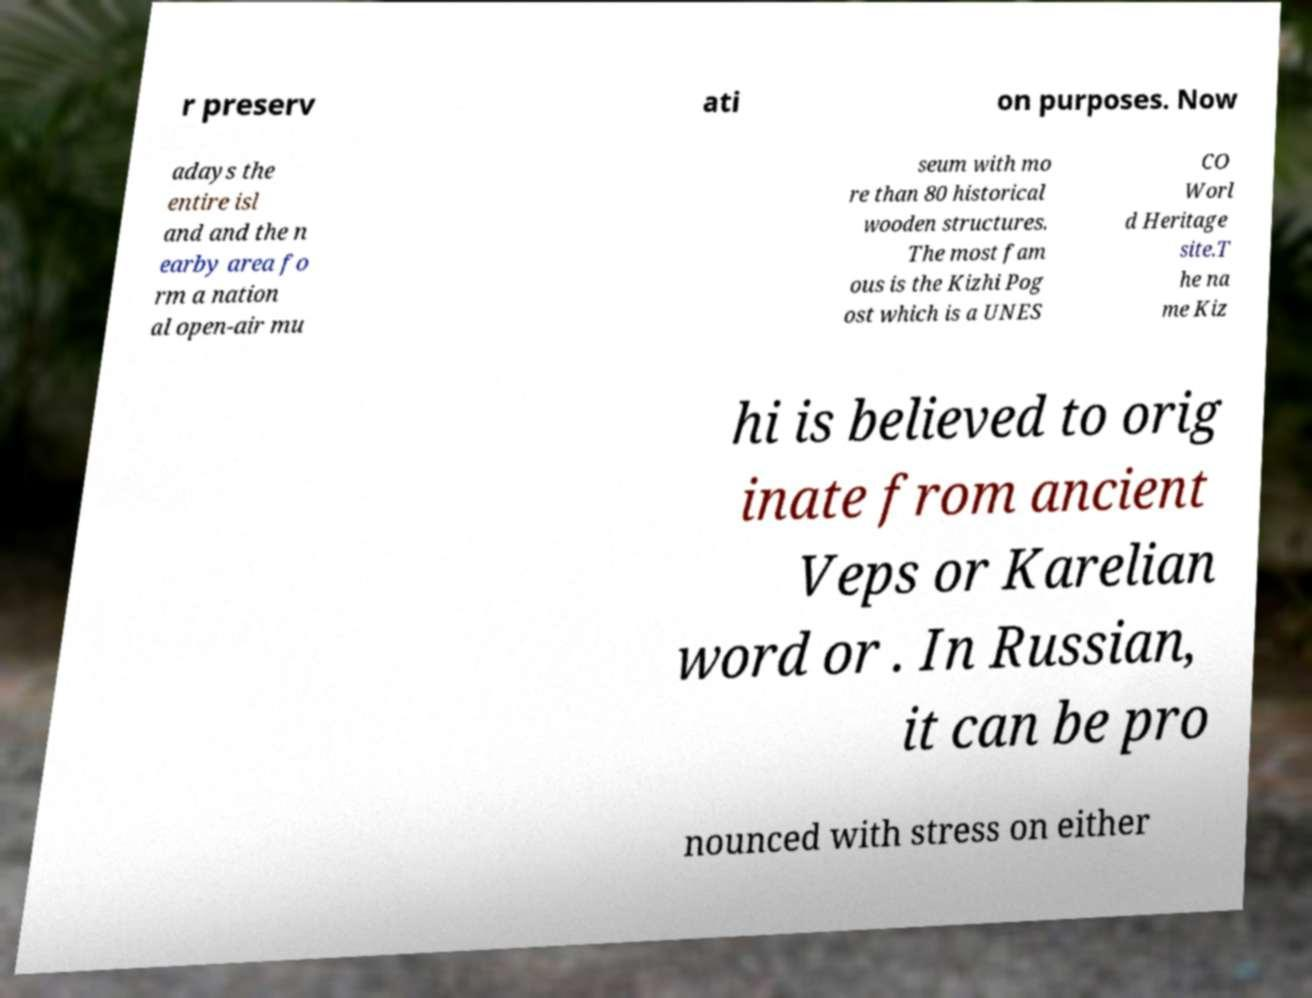Can you read and provide the text displayed in the image?This photo seems to have some interesting text. Can you extract and type it out for me? r preserv ati on purposes. Now adays the entire isl and and the n earby area fo rm a nation al open-air mu seum with mo re than 80 historical wooden structures. The most fam ous is the Kizhi Pog ost which is a UNES CO Worl d Heritage site.T he na me Kiz hi is believed to orig inate from ancient Veps or Karelian word or . In Russian, it can be pro nounced with stress on either 